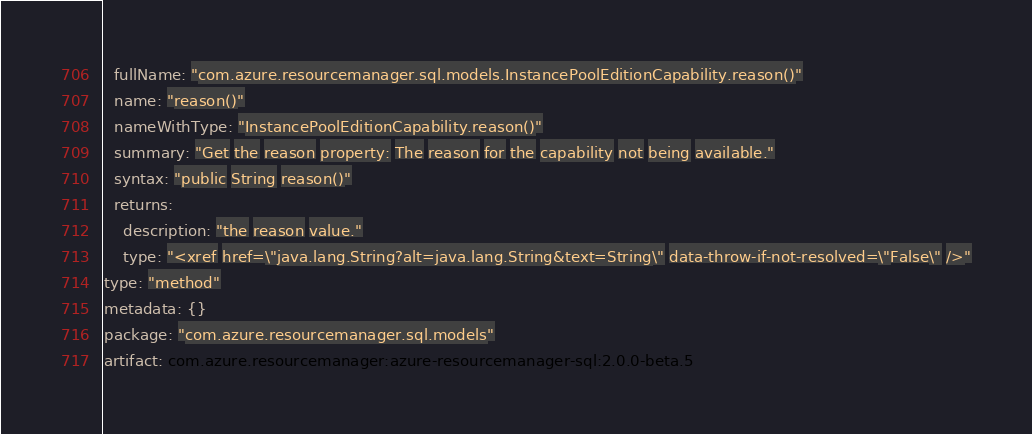Convert code to text. <code><loc_0><loc_0><loc_500><loc_500><_YAML_>  fullName: "com.azure.resourcemanager.sql.models.InstancePoolEditionCapability.reason()"
  name: "reason()"
  nameWithType: "InstancePoolEditionCapability.reason()"
  summary: "Get the reason property: The reason for the capability not being available."
  syntax: "public String reason()"
  returns:
    description: "the reason value."
    type: "<xref href=\"java.lang.String?alt=java.lang.String&text=String\" data-throw-if-not-resolved=\"False\" />"
type: "method"
metadata: {}
package: "com.azure.resourcemanager.sql.models"
artifact: com.azure.resourcemanager:azure-resourcemanager-sql:2.0.0-beta.5
</code> 